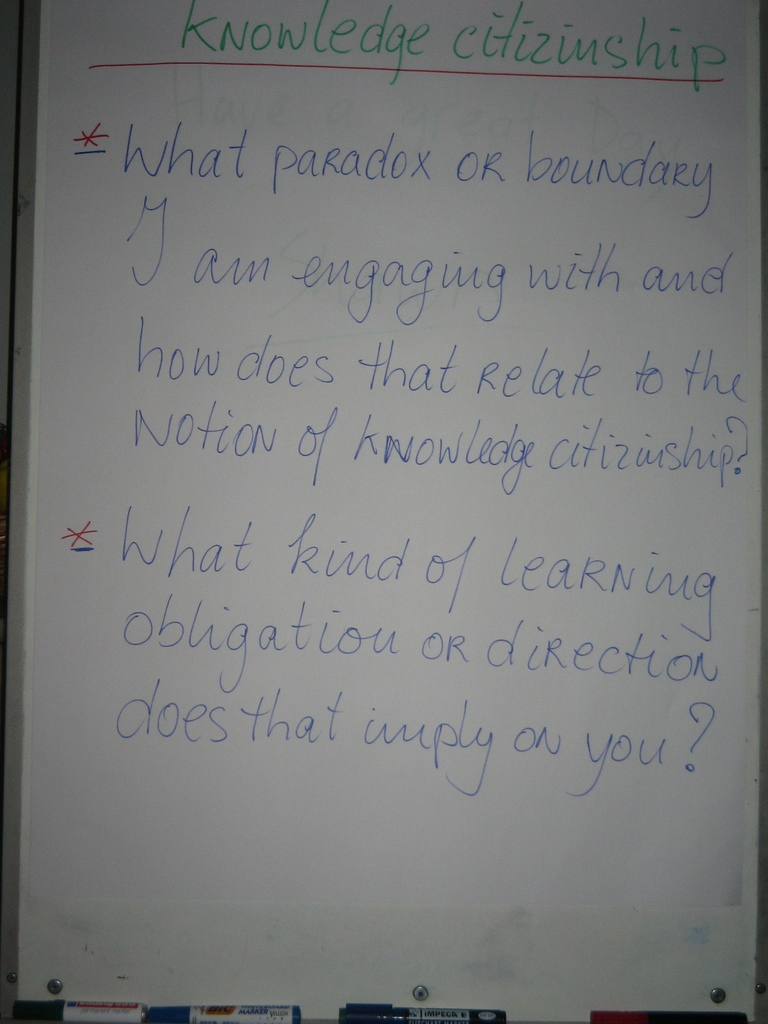How might an individual's paradox or boundary challenge influence their role in a community? An individual's engagement with personal paradoxes or boundary challenges can significantly influence their role in a community. By facing and addressing these challenges, an individual may gain unique insights and perspectives that contribute to a more diverse and resilient community. They may also become more empathetic and supportive of others facing similar issues, which can foster a stronger sense of unity and collective growth. What are some examples of learning obligations that might arise from these kinds of challenges? Learning obligations could include the responsibility to share one's findings and experiences with the community, seeking out further education to address gaps in understanding, or mentoring others. It may also mean advocating for changes in the community that accommodate new knowledge or the removal of barriers to learning, ensuring that the community evolves with its members' personal growth. 